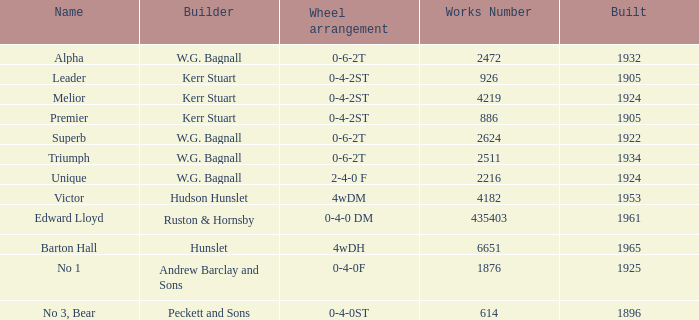What is the contact number for victor's workplace? 4182.0. 